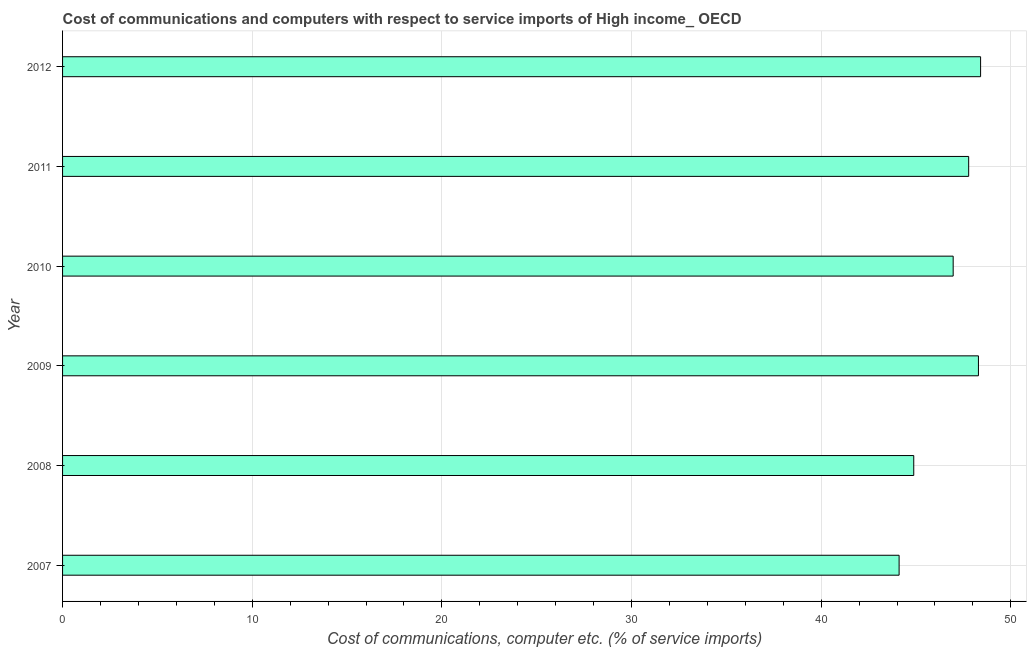Does the graph contain any zero values?
Give a very brief answer. No. Does the graph contain grids?
Give a very brief answer. Yes. What is the title of the graph?
Your answer should be compact. Cost of communications and computers with respect to service imports of High income_ OECD. What is the label or title of the X-axis?
Offer a very short reply. Cost of communications, computer etc. (% of service imports). What is the cost of communications and computer in 2009?
Your response must be concise. 48.29. Across all years, what is the maximum cost of communications and computer?
Provide a short and direct response. 48.41. Across all years, what is the minimum cost of communications and computer?
Your answer should be very brief. 44.11. What is the sum of the cost of communications and computer?
Give a very brief answer. 280.44. What is the difference between the cost of communications and computer in 2008 and 2009?
Provide a succinct answer. -3.41. What is the average cost of communications and computer per year?
Ensure brevity in your answer.  46.74. What is the median cost of communications and computer?
Your answer should be very brief. 47.37. Do a majority of the years between 2011 and 2007 (inclusive) have cost of communications and computer greater than 14 %?
Offer a very short reply. Yes. What is the ratio of the cost of communications and computer in 2009 to that in 2011?
Your answer should be very brief. 1.01. What is the difference between the highest and the second highest cost of communications and computer?
Offer a terse response. 0.11. What is the difference between the highest and the lowest cost of communications and computer?
Give a very brief answer. 4.3. In how many years, is the cost of communications and computer greater than the average cost of communications and computer taken over all years?
Give a very brief answer. 4. How many years are there in the graph?
Make the answer very short. 6. What is the Cost of communications, computer etc. (% of service imports) of 2007?
Keep it short and to the point. 44.11. What is the Cost of communications, computer etc. (% of service imports) in 2008?
Your response must be concise. 44.88. What is the Cost of communications, computer etc. (% of service imports) in 2009?
Give a very brief answer. 48.29. What is the Cost of communications, computer etc. (% of service imports) in 2010?
Provide a short and direct response. 46.96. What is the Cost of communications, computer etc. (% of service imports) of 2011?
Your answer should be very brief. 47.78. What is the Cost of communications, computer etc. (% of service imports) of 2012?
Your answer should be very brief. 48.41. What is the difference between the Cost of communications, computer etc. (% of service imports) in 2007 and 2008?
Keep it short and to the point. -0.77. What is the difference between the Cost of communications, computer etc. (% of service imports) in 2007 and 2009?
Offer a terse response. -4.18. What is the difference between the Cost of communications, computer etc. (% of service imports) in 2007 and 2010?
Give a very brief answer. -2.85. What is the difference between the Cost of communications, computer etc. (% of service imports) in 2007 and 2011?
Your response must be concise. -3.67. What is the difference between the Cost of communications, computer etc. (% of service imports) in 2007 and 2012?
Ensure brevity in your answer.  -4.3. What is the difference between the Cost of communications, computer etc. (% of service imports) in 2008 and 2009?
Keep it short and to the point. -3.41. What is the difference between the Cost of communications, computer etc. (% of service imports) in 2008 and 2010?
Offer a terse response. -2.08. What is the difference between the Cost of communications, computer etc. (% of service imports) in 2008 and 2011?
Your answer should be compact. -2.9. What is the difference between the Cost of communications, computer etc. (% of service imports) in 2008 and 2012?
Ensure brevity in your answer.  -3.52. What is the difference between the Cost of communications, computer etc. (% of service imports) in 2009 and 2010?
Your answer should be very brief. 1.33. What is the difference between the Cost of communications, computer etc. (% of service imports) in 2009 and 2011?
Offer a very short reply. 0.51. What is the difference between the Cost of communications, computer etc. (% of service imports) in 2009 and 2012?
Make the answer very short. -0.11. What is the difference between the Cost of communications, computer etc. (% of service imports) in 2010 and 2011?
Your answer should be very brief. -0.82. What is the difference between the Cost of communications, computer etc. (% of service imports) in 2010 and 2012?
Ensure brevity in your answer.  -1.45. What is the difference between the Cost of communications, computer etc. (% of service imports) in 2011 and 2012?
Provide a succinct answer. -0.63. What is the ratio of the Cost of communications, computer etc. (% of service imports) in 2007 to that in 2008?
Your answer should be compact. 0.98. What is the ratio of the Cost of communications, computer etc. (% of service imports) in 2007 to that in 2010?
Offer a very short reply. 0.94. What is the ratio of the Cost of communications, computer etc. (% of service imports) in 2007 to that in 2011?
Provide a short and direct response. 0.92. What is the ratio of the Cost of communications, computer etc. (% of service imports) in 2007 to that in 2012?
Offer a terse response. 0.91. What is the ratio of the Cost of communications, computer etc. (% of service imports) in 2008 to that in 2009?
Provide a short and direct response. 0.93. What is the ratio of the Cost of communications, computer etc. (% of service imports) in 2008 to that in 2010?
Your answer should be compact. 0.96. What is the ratio of the Cost of communications, computer etc. (% of service imports) in 2008 to that in 2011?
Ensure brevity in your answer.  0.94. What is the ratio of the Cost of communications, computer etc. (% of service imports) in 2008 to that in 2012?
Give a very brief answer. 0.93. What is the ratio of the Cost of communications, computer etc. (% of service imports) in 2009 to that in 2010?
Give a very brief answer. 1.03. What is the ratio of the Cost of communications, computer etc. (% of service imports) in 2009 to that in 2011?
Offer a very short reply. 1.01. What is the ratio of the Cost of communications, computer etc. (% of service imports) in 2009 to that in 2012?
Offer a very short reply. 1. 